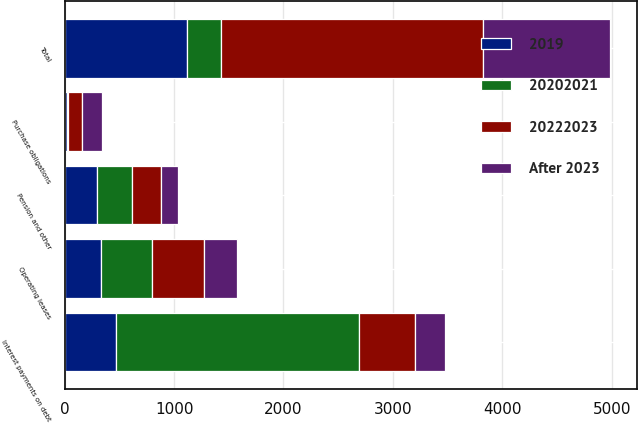Convert chart. <chart><loc_0><loc_0><loc_500><loc_500><stacked_bar_chart><ecel><fcel>Interest payments on debt<fcel>Operating leases<fcel>Pension and other<fcel>Purchase obligations<fcel>Total<nl><fcel>After 2023<fcel>275<fcel>303<fcel>150<fcel>179<fcel>1158<nl><fcel>20222023<fcel>514<fcel>474<fcel>270<fcel>132<fcel>2390<nl><fcel>2019<fcel>467<fcel>330<fcel>298<fcel>24<fcel>1119<nl><fcel>20202021<fcel>2220<fcel>472<fcel>314<fcel>5<fcel>314<nl></chart> 